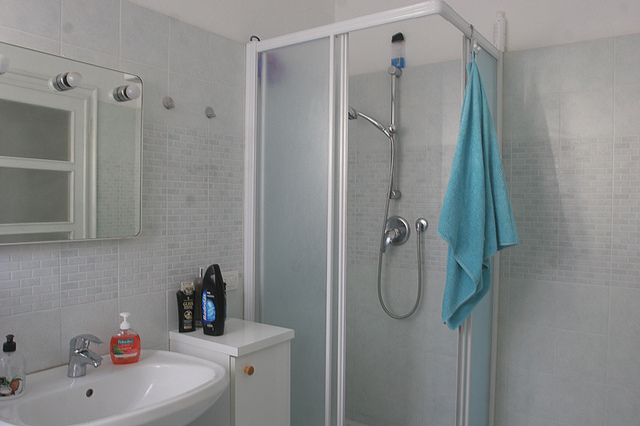Which items can be seen on the sink countertop? On the sink countertop, there are a liquid soap dispenser and a blue shampoo bottle. 